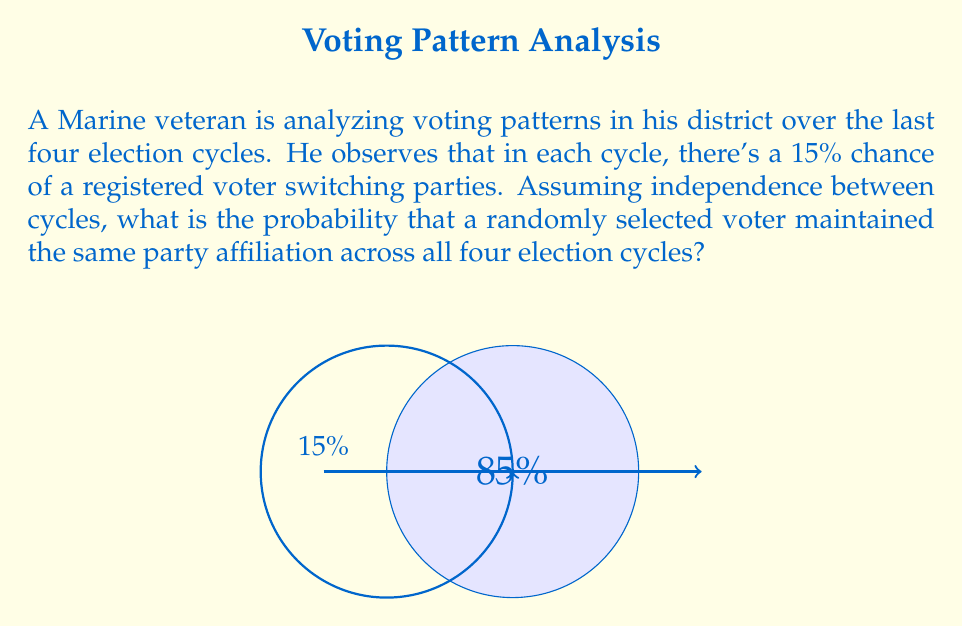Can you answer this question? Let's approach this step-by-step:

1) First, we need to identify the probability of a voter maintaining their party affiliation in a single election cycle. This is the complement of the probability of switching:

   $P(\text{maintain}) = 1 - P(\text{switch}) = 1 - 0.15 = 0.85$ or 85%

2) Now, we need to consider all four election cycles. For a voter to maintain the same party affiliation across all four cycles, they must maintain it in the first AND second AND third AND fourth cycle.

3) Since we're assuming independence between cycles, we can use the multiplication rule of probability. The probability of independent events all occurring is the product of their individual probabilities.

4) Therefore, the probability of maintaining the same affiliation across all four cycles is:

   $$P(\text{maintain all 4}) = 0.85 \times 0.85 \times 0.85 \times 0.85 = 0.85^4$$

5) Let's calculate this:

   $$0.85^4 = 0.5220890625$$

6) Converting to a percentage:

   $$0.5220890625 \times 100\% = 52.21\%$$

Thus, there is approximately a 52.21% chance that a randomly selected voter maintained the same party affiliation across all four election cycles.
Answer: $52.21\%$ 